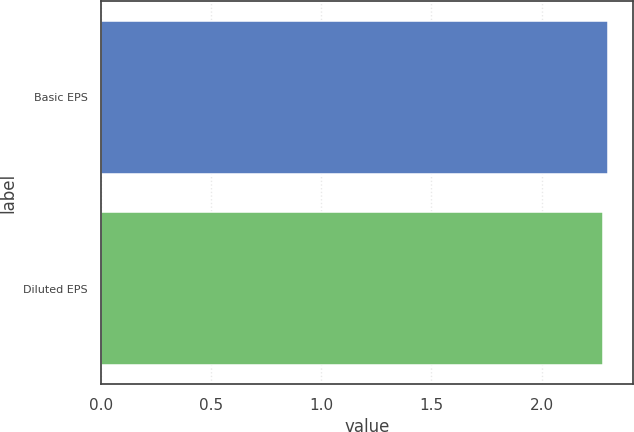<chart> <loc_0><loc_0><loc_500><loc_500><bar_chart><fcel>Basic EPS<fcel>Diluted EPS<nl><fcel>2.3<fcel>2.28<nl></chart> 